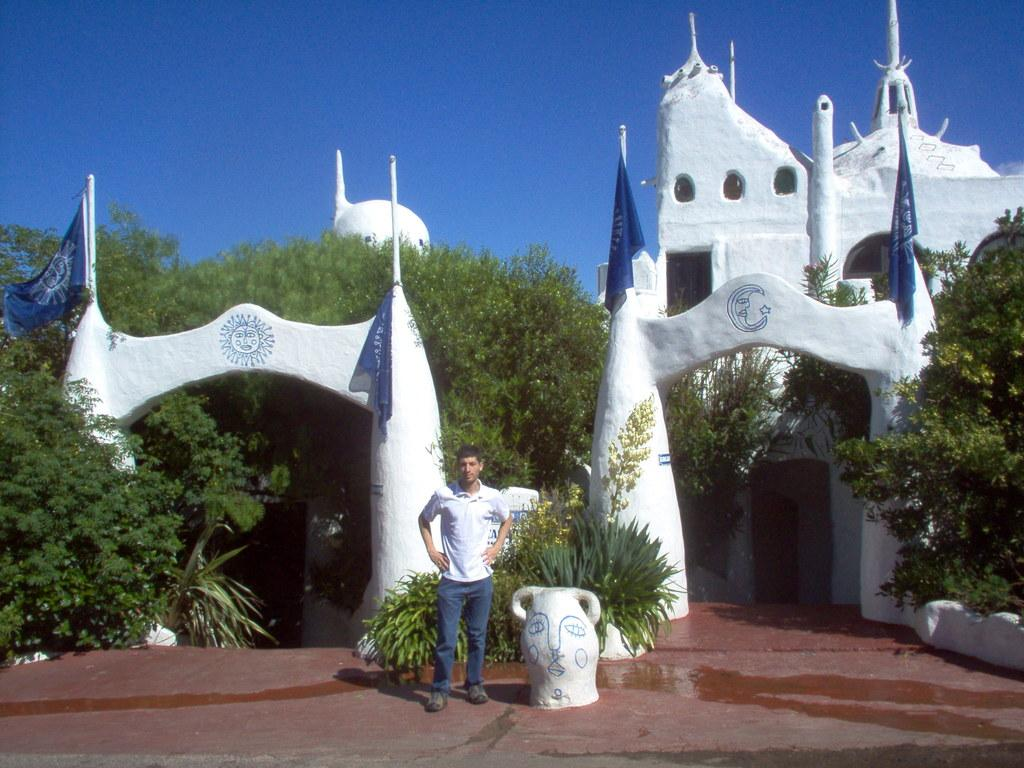What is the main subject of the image? There is a person standing in the image. Can you describe the person's attire? The person is wearing clothes. What other natural elements can be seen in the image? There is a plant, trees, and a blue sky in the image. Are there any man-made structures visible? Yes, there is a white building in the image. What type of path is present in the image? There is a footpath in the image. How many flags are visible, and where are they positioned? There are flags in the image, but their exact number and position cannot be determined from the provided facts. What type of bait is being used to catch fish in the image? There is no indication of fishing or bait in the image. How much money is the person holding in the image? There is no money visible in the image. 